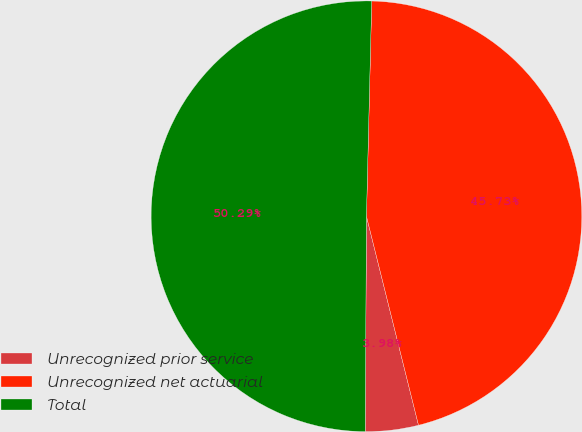Convert chart. <chart><loc_0><loc_0><loc_500><loc_500><pie_chart><fcel>Unrecognized prior service<fcel>Unrecognized net actuarial<fcel>Total<nl><fcel>3.98%<fcel>45.73%<fcel>50.3%<nl></chart> 